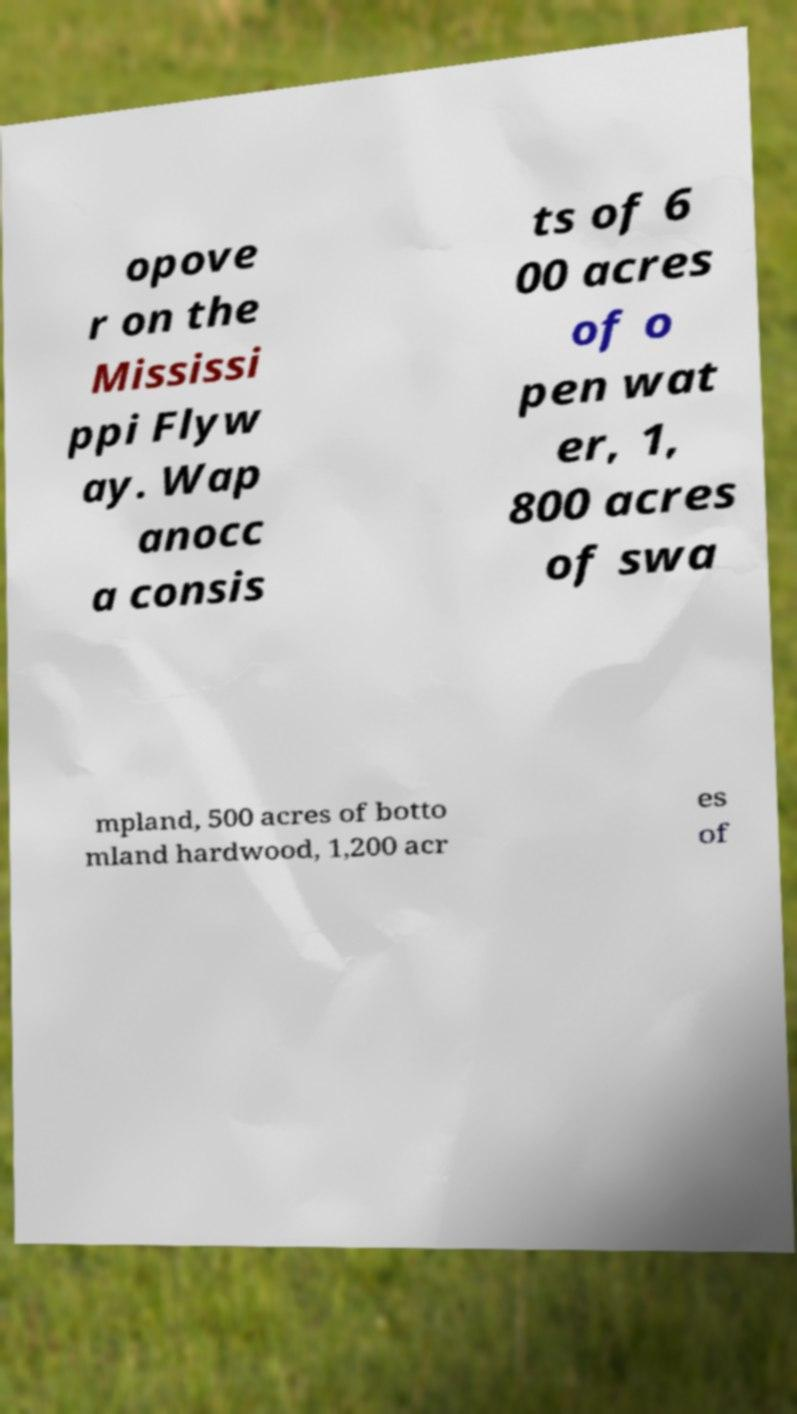For documentation purposes, I need the text within this image transcribed. Could you provide that? opove r on the Mississi ppi Flyw ay. Wap anocc a consis ts of 6 00 acres of o pen wat er, 1, 800 acres of swa mpland, 500 acres of botto mland hardwood, 1,200 acr es of 